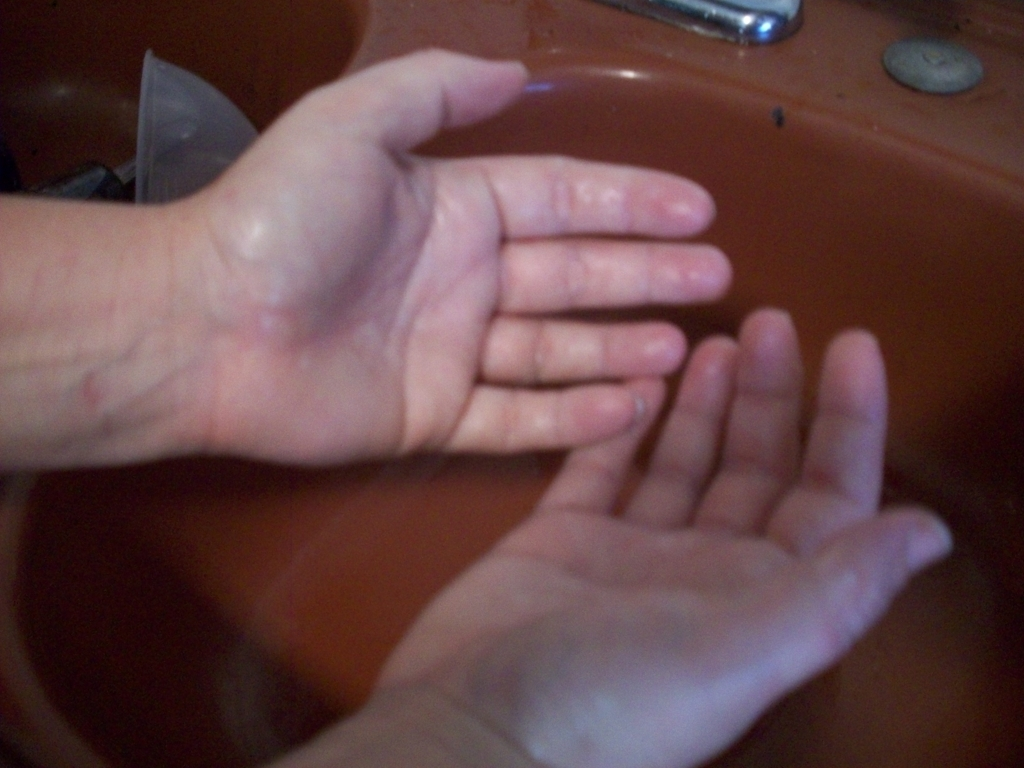Is the background significantly blurred? The background does exhibit some blur, which reduces the level of detail and contrast. However, this blurring does not significantly obscure the main subject of the image, which is a pair of hands under running water. The focus remains on the hands, suggestive of an action like washing. 